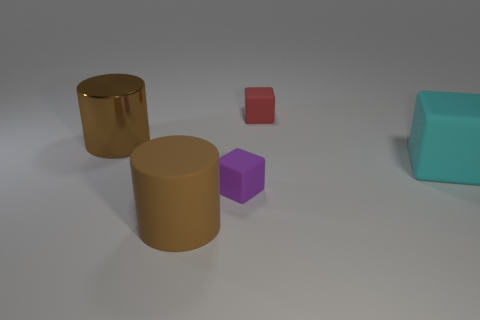There is a red thing that is the same shape as the small purple matte object; what size is it?
Provide a succinct answer. Small. Does the block that is behind the big cyan rubber block have the same material as the small purple object?
Your response must be concise. Yes. The cylinder that is the same material as the red object is what size?
Keep it short and to the point. Large. There is a large rubber object to the left of the cyan thing; is it the same color as the cylinder behind the brown rubber cylinder?
Your answer should be very brief. Yes. How big is the purple rubber object on the right side of the large rubber cylinder?
Provide a succinct answer. Small. How many other things are there of the same size as the brown metal cylinder?
Keep it short and to the point. 2. Is the shiny thing the same color as the big rubber cylinder?
Your response must be concise. Yes. Do the small matte thing that is in front of the red object and the tiny red rubber thing have the same shape?
Provide a succinct answer. Yes. How many matte blocks are both behind the big cyan cube and to the left of the red object?
Your response must be concise. 0. What is the red thing made of?
Give a very brief answer. Rubber. 